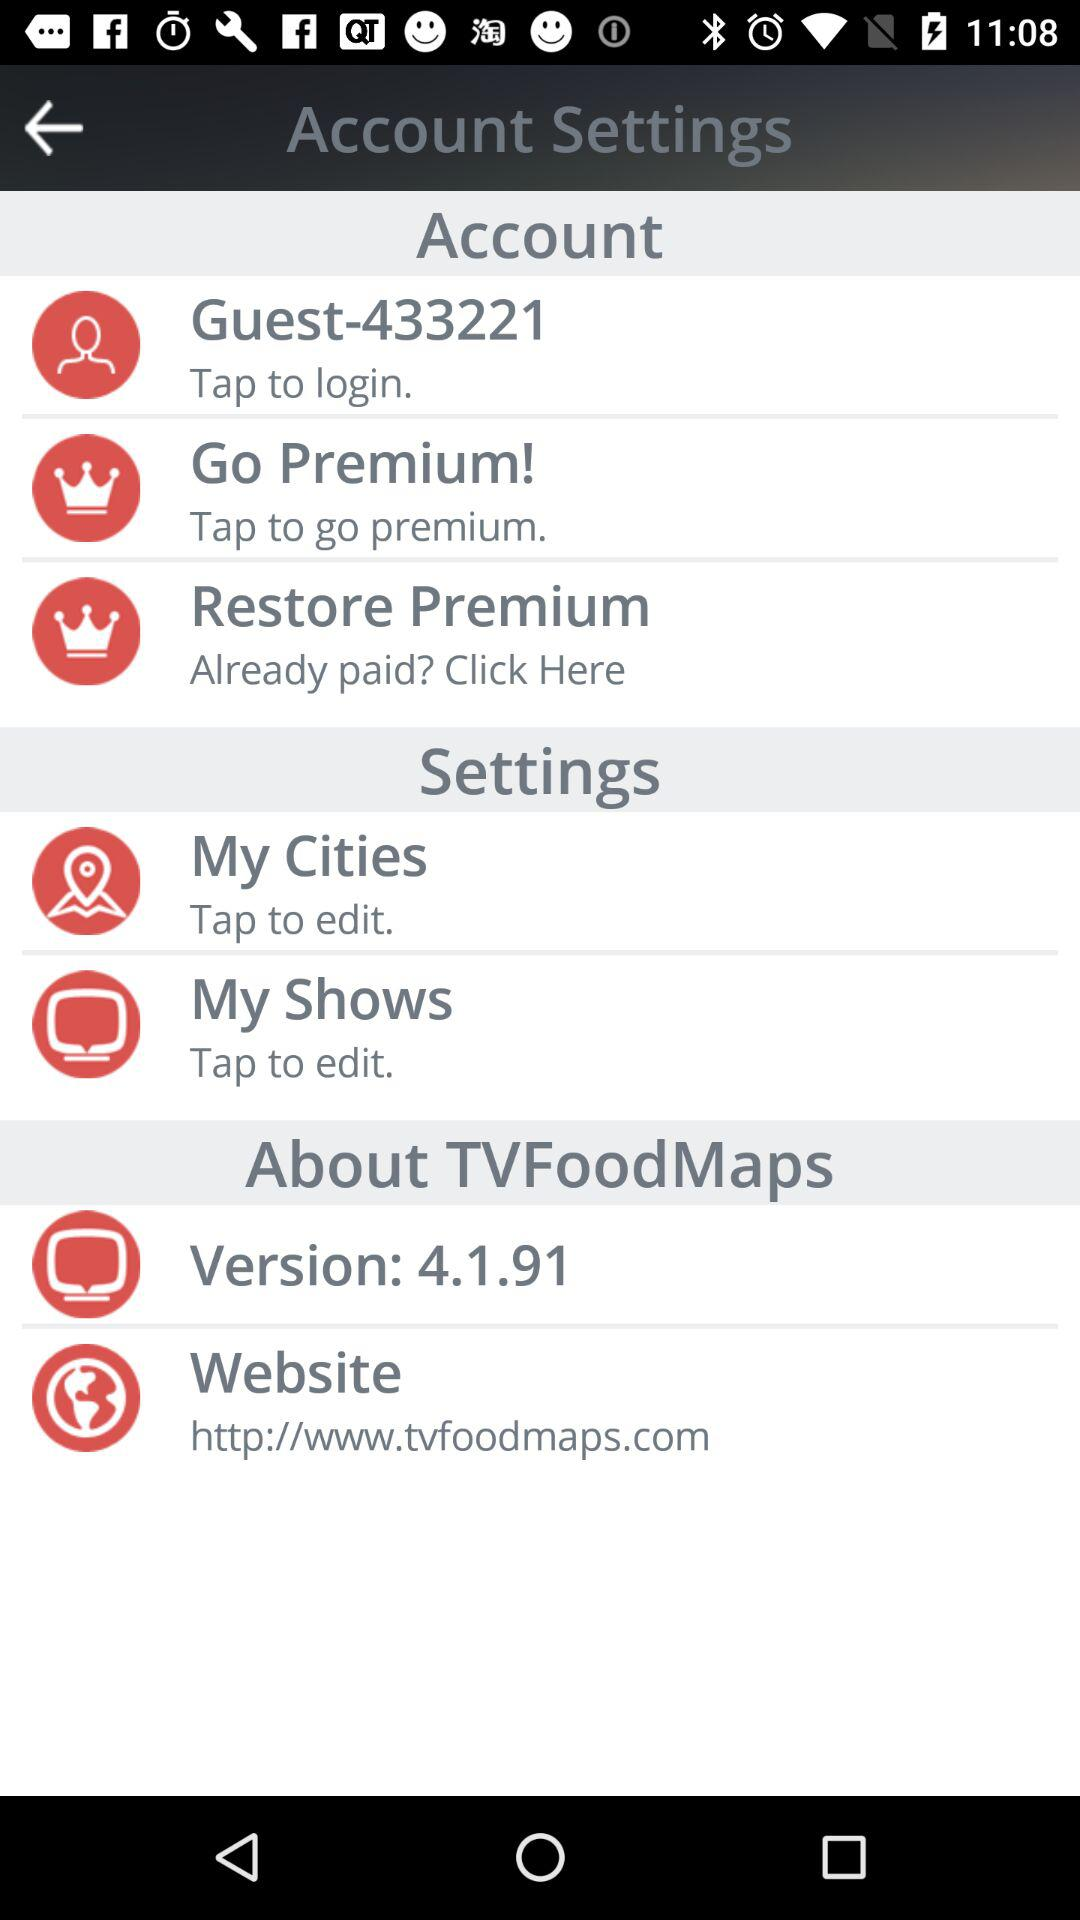What is the version of "TVFoodMaps"? The version is 4.1.91. 